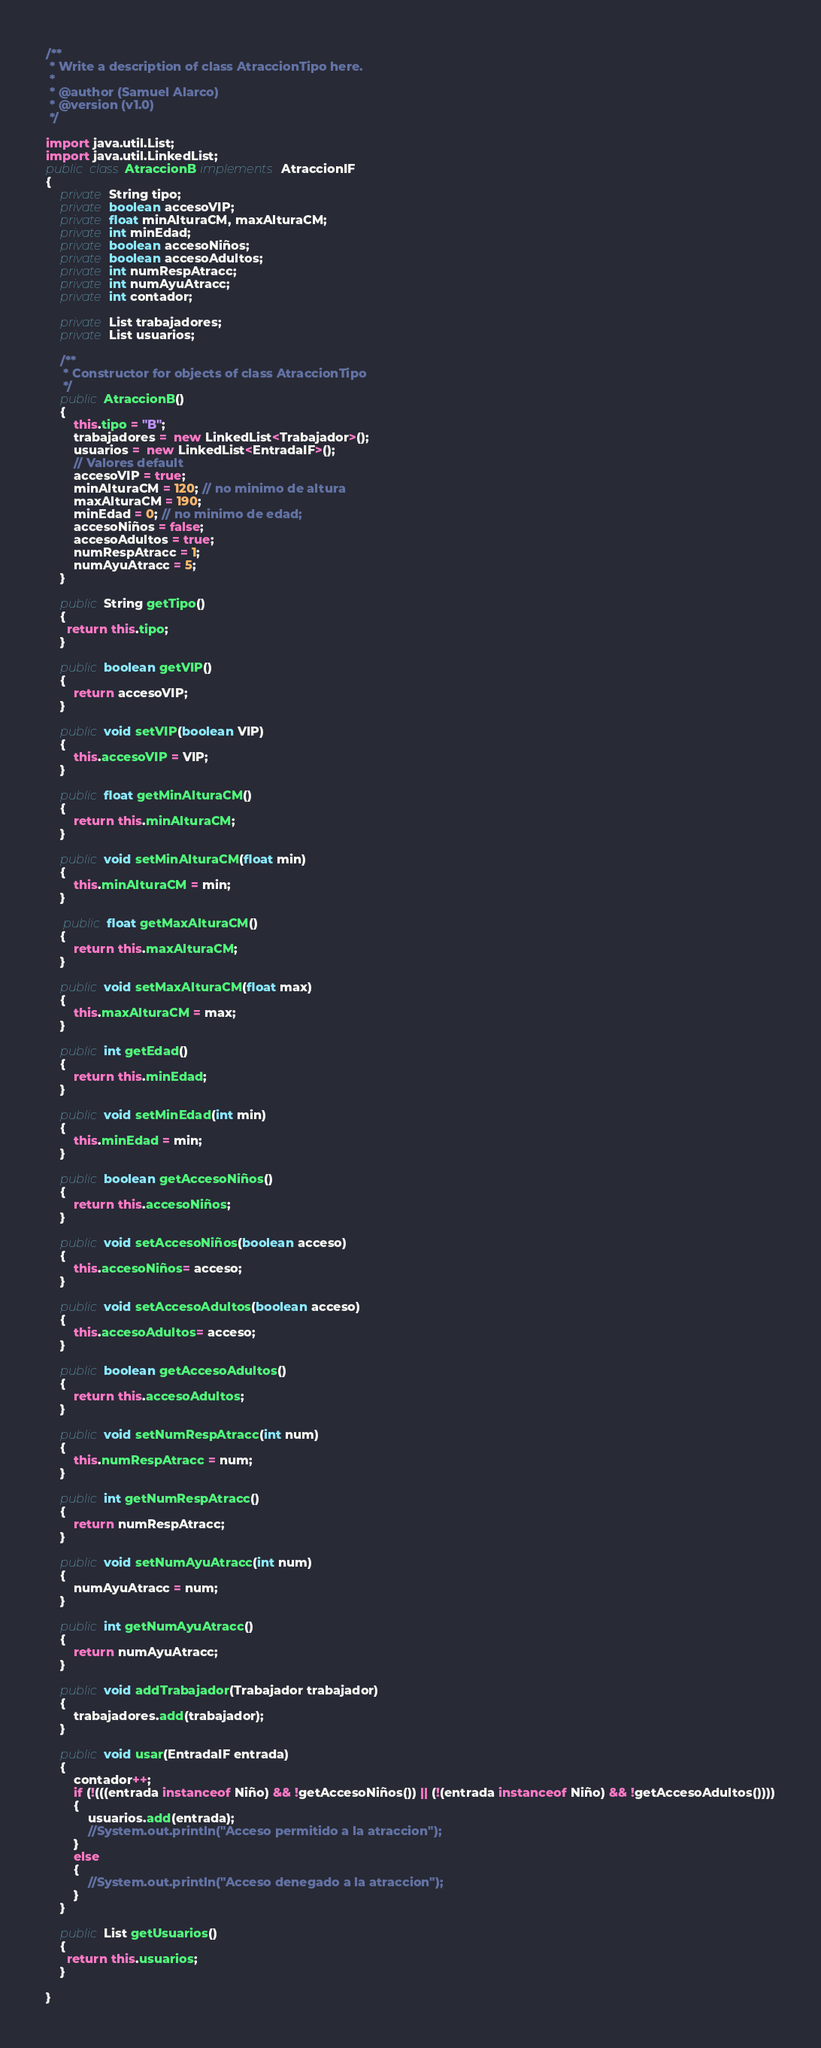Convert code to text. <code><loc_0><loc_0><loc_500><loc_500><_Java_>
/**
 * Write a description of class AtraccionTipo here.
 *
 * @author (Samuel Alarco)
 * @version (v1.0)
 */

import java.util.List;
import java.util.LinkedList;
public class AtraccionB implements AtraccionIF
{
    private String tipo;
    private boolean accesoVIP;
    private float minAlturaCM, maxAlturaCM;
    private int minEdad;
    private boolean accesoNiños;
    private boolean accesoAdultos;
    private int numRespAtracc;
    private int numAyuAtracc;
    private int contador;

    private List trabajadores;
    private List usuarios;

    /**
     * Constructor for objects of class AtraccionTipo
     */
    public AtraccionB()
    {
        this.tipo = "B";
        trabajadores =  new LinkedList<Trabajador>();
        usuarios =  new LinkedList<EntradaIF>();
        // Valores default
        accesoVIP = true;
        minAlturaCM = 120; // no minimo de altura
        maxAlturaCM = 190;
        minEdad = 0; // no minimo de edad;
        accesoNiños = false;
        accesoAdultos = true;
        numRespAtracc = 1;
        numAyuAtracc = 5;
    }

    public String getTipo()
    {
      return this.tipo;
    }

    public boolean getVIP()
    {
        return accesoVIP;
    }

    public void setVIP(boolean VIP)
    {
        this.accesoVIP = VIP;
    }

    public float getMinAlturaCM()
    {
        return this.minAlturaCM;
    }

    public void setMinAlturaCM(float min)
    {
        this.minAlturaCM = min;
    }

     public float getMaxAlturaCM()
    {
        return this.maxAlturaCM;
    }

    public void setMaxAlturaCM(float max)
    {
        this.maxAlturaCM = max;
    }

    public int getEdad()
    {
        return this.minEdad;
    }

    public void setMinEdad(int min)
    {
        this.minEdad = min;
    }

    public boolean getAccesoNiños()
    {
        return this.accesoNiños;
    }

    public void setAccesoNiños(boolean acceso)
    {
        this.accesoNiños= acceso;
    }

    public void setAccesoAdultos(boolean acceso)
    {
        this.accesoAdultos= acceso;
    }

    public boolean getAccesoAdultos()
    {
        return this.accesoAdultos;
    }

    public void setNumRespAtracc(int num)
    {
        this.numRespAtracc = num;
    }

    public int getNumRespAtracc()
    {
        return numRespAtracc;
    }

    public void setNumAyuAtracc(int num)
    {
        numAyuAtracc = num;
    }

    public int getNumAyuAtracc()
    {
        return numAyuAtracc;
    }

    public void addTrabajador(Trabajador trabajador)
    {
        trabajadores.add(trabajador);
    }

    public void usar(EntradaIF entrada)
    {
        contador++;
        if (!(((entrada instanceof Niño) && !getAccesoNiños()) || (!(entrada instanceof Niño) && !getAccesoAdultos())))
        {
            usuarios.add(entrada);
            //System.out.println("Acceso permitido a la atraccion");
        }
        else
        {
            //System.out.println("Acceso denegado a la atraccion");
        }
    }

    public List getUsuarios()
    {
      return this.usuarios;
    }

}
</code> 